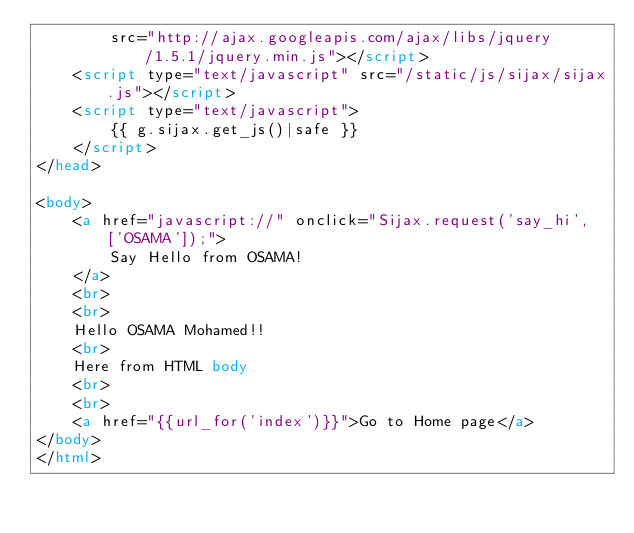Convert code to text. <code><loc_0><loc_0><loc_500><loc_500><_HTML_>        src="http://ajax.googleapis.com/ajax/libs/jquery/1.5.1/jquery.min.js"></script>
    <script type="text/javascript" src="/static/js/sijax/sijax.js"></script>
    <script type="text/javascript">
        {{ g.sijax.get_js()|safe }}
    </script>
</head>

<body>
    <a href="javascript://" onclick="Sijax.request('say_hi', ['OSAMA']);">
        Say Hello from OSAMA!
    </a>
    <br>
    <br>
    Hello OSAMA Mohamed!!
    <br>
    Here from HTML body
    <br>
    <br>
    <a href="{{url_for('index')}}">Go to Home page</a>
</body>
</html></code> 